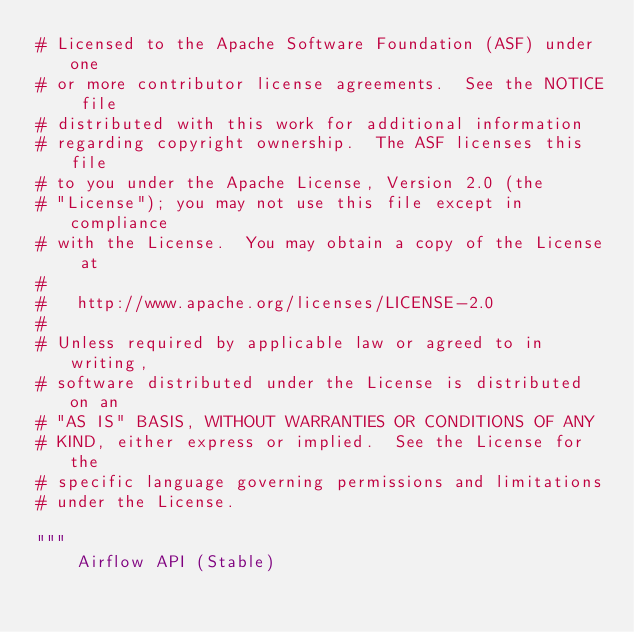<code> <loc_0><loc_0><loc_500><loc_500><_Python_># Licensed to the Apache Software Foundation (ASF) under one
# or more contributor license agreements.  See the NOTICE file
# distributed with this work for additional information
# regarding copyright ownership.  The ASF licenses this file
# to you under the Apache License, Version 2.0 (the
# "License"); you may not use this file except in compliance
# with the License.  You may obtain a copy of the License at
#
#   http://www.apache.org/licenses/LICENSE-2.0
#
# Unless required by applicable law or agreed to in writing,
# software distributed under the License is distributed on an
# "AS IS" BASIS, WITHOUT WARRANTIES OR CONDITIONS OF ANY
# KIND, either express or implied.  See the License for the
# specific language governing permissions and limitations
# under the License.

"""
    Airflow API (Stable)
</code> 